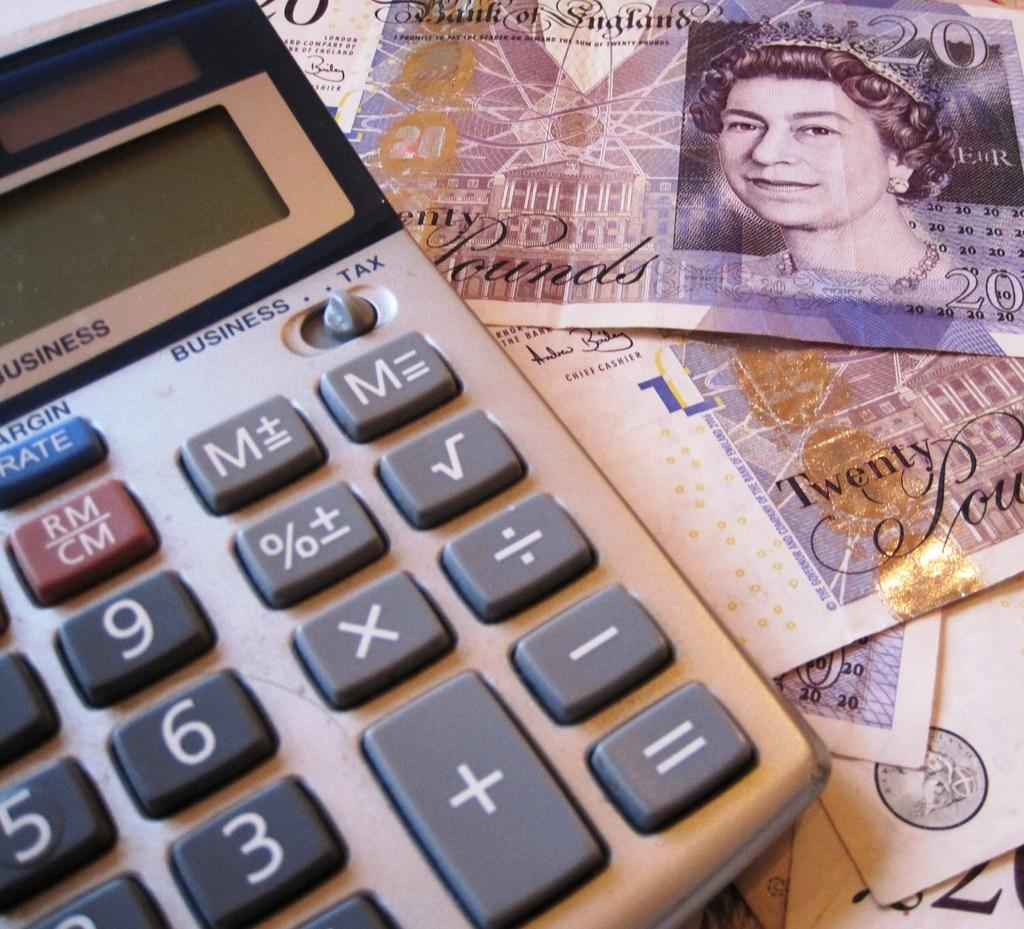<image>
Share a concise interpretation of the image provided. Some Euro money next to a calculator that says Business or tax. 